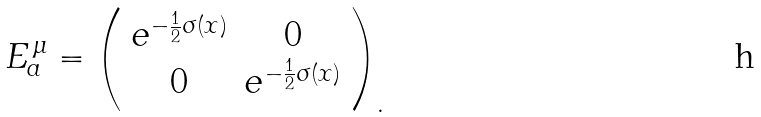Convert formula to latex. <formula><loc_0><loc_0><loc_500><loc_500>E ^ { \, \mu } _ { a } = \left ( \begin{array} { c c } e ^ { - \frac { 1 } { 2 } \sigma ( x ) } & 0 \\ 0 & e ^ { - \frac { 1 } { 2 } \sigma ( x ) } \end{array} \right ) _ { . }</formula> 